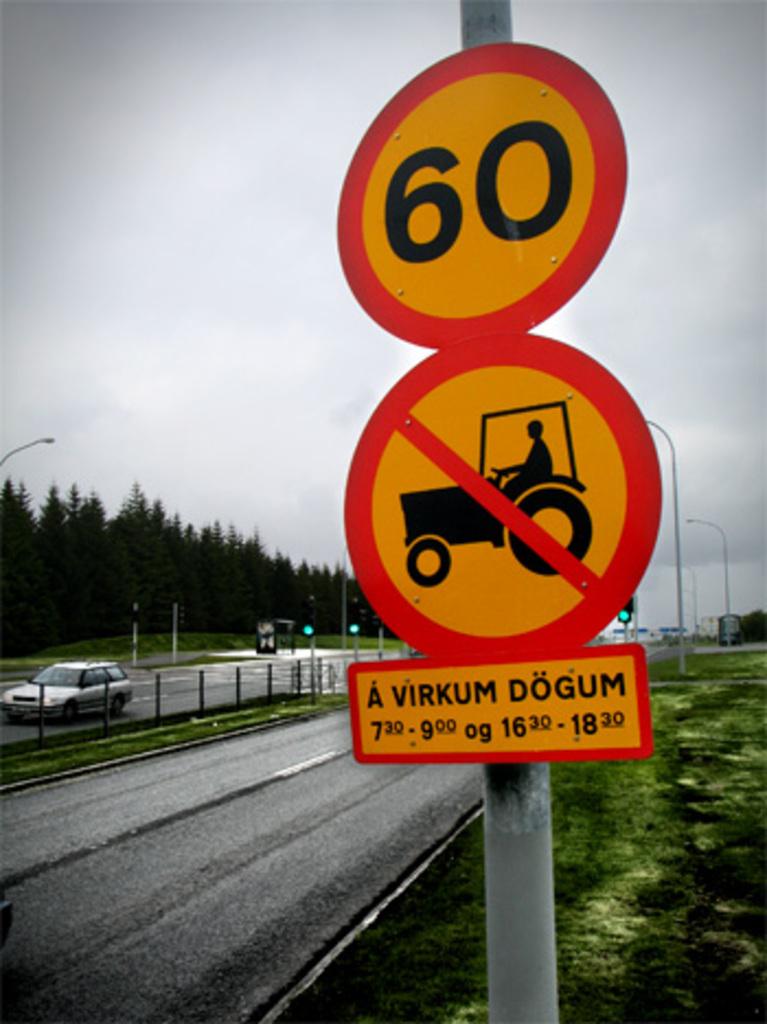How fast is this sign telling you to go?
Provide a short and direct response. 60. 